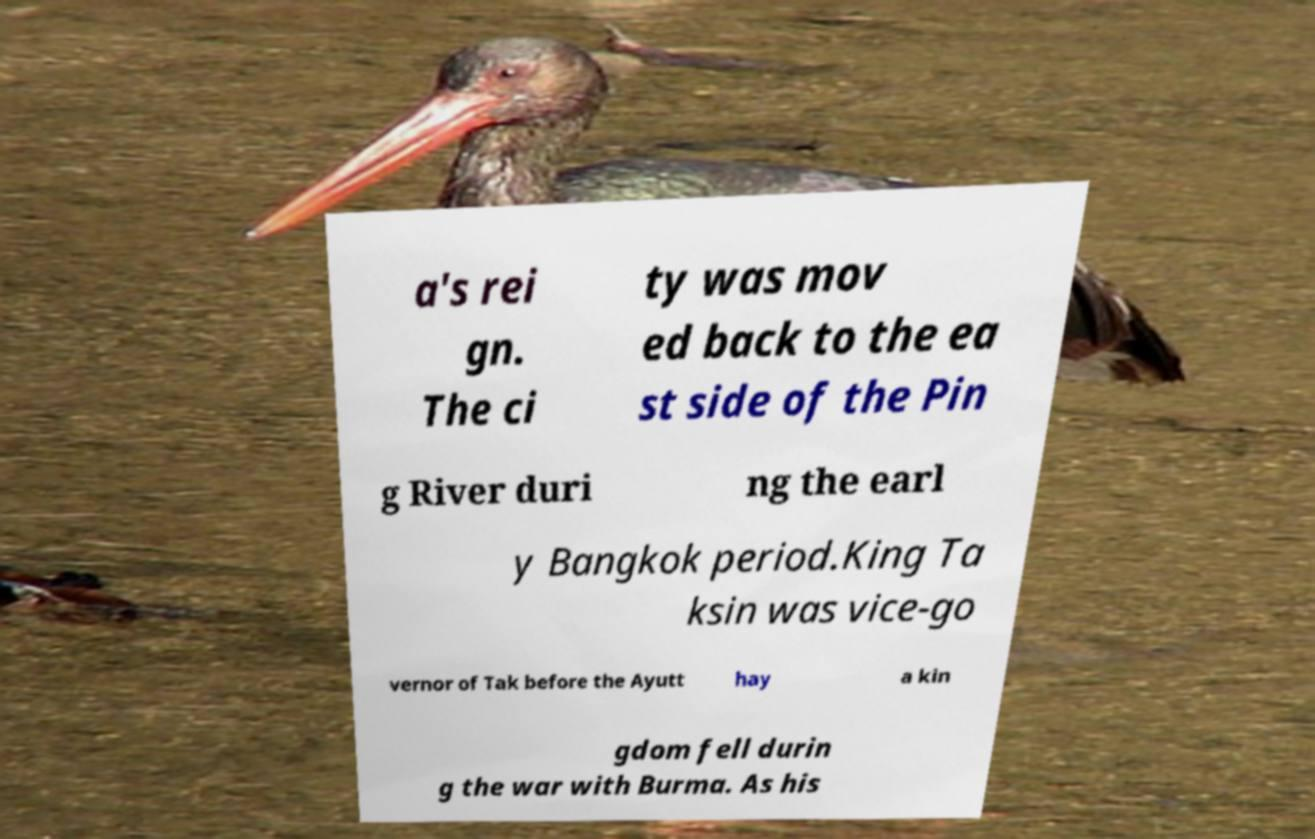What messages or text are displayed in this image? I need them in a readable, typed format. a's rei gn. The ci ty was mov ed back to the ea st side of the Pin g River duri ng the earl y Bangkok period.King Ta ksin was vice-go vernor of Tak before the Ayutt hay a kin gdom fell durin g the war with Burma. As his 